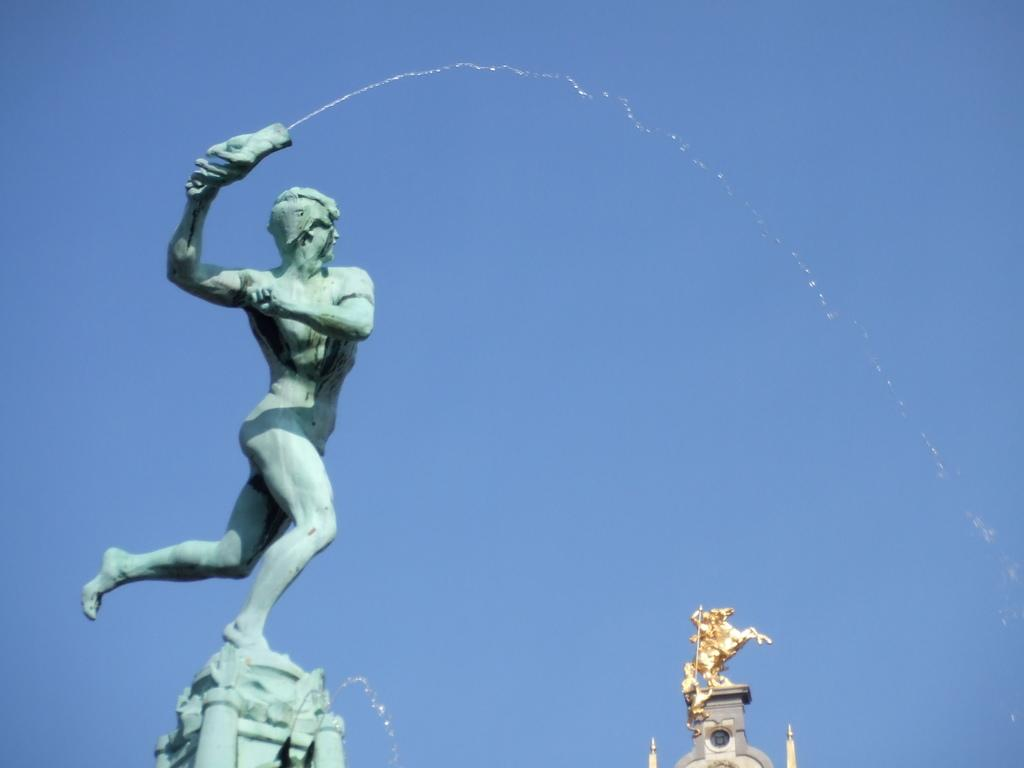What can be seen in the image? There are statues in the image. What is visible in the background of the image? The sky is visible in the background of the image. How many people are stretching their fingers in the image? There are no people present in the image, and therefore no one is stretching their fingers. 